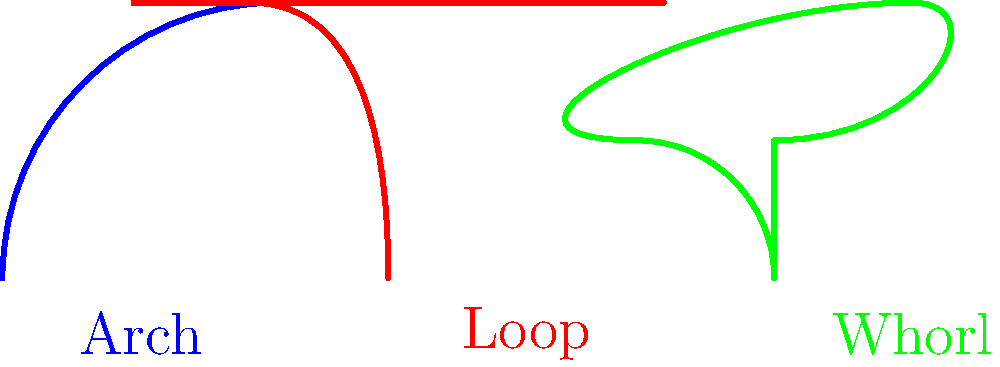As a non-fiction book publisher interested in publishing a detective's memoir, you come across a section discussing fingerprint classification. The image shows three common fingerprint patterns. Which pattern is most likely to provide the highest level of uniqueness and why would this be significant for a detective's work? To answer this question, let's analyze the three fingerprint patterns shown in the image:

1. Arch (blue): A simple pattern where ridges enter from one side, rise in the middle, and exit on the other side.
2. Loop (red): Ridges enter from one side, curve back, and exit on the same side.
3. Whorl (green): A circular or spiral pattern with two or more deltas.

The level of uniqueness in fingerprints is generally determined by the complexity and number of identifying features, called minutiae. These include ridge endings, bifurcations, and other details.

Step-by-step analysis:
1. Arches are the simplest pattern, with fewer minutiae points.
2. Loops are more complex than arches, offering more minutiae points.
3. Whorls are the most complex of these three patterns, typically containing the highest number of minutiae points.

The whorl pattern, due to its circular nature and multiple deltas, provides the most opportunities for unique identifying features. This higher level of uniqueness is significant for a detective's work because:

1. It increases the likelihood of making a positive identification.
2. It reduces the chances of false matches in large databases.
3. It provides more points for comparison when only partial prints are available.

For a detective, this means more reliable evidence and potentially stronger cases when fingerprint evidence is crucial.
Answer: Whorl pattern; highest complexity and uniqueness aid in accurate identification. 